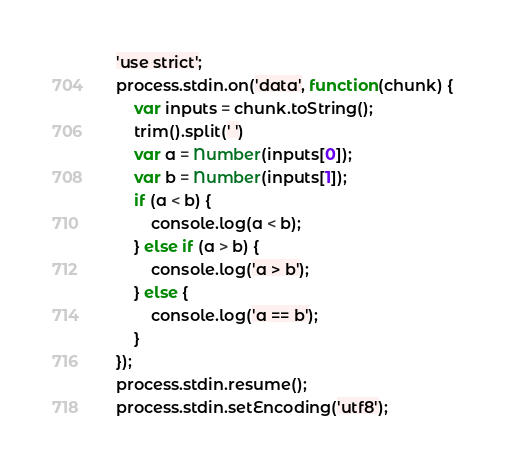Convert code to text. <code><loc_0><loc_0><loc_500><loc_500><_JavaScript_>'use strict';
process.stdin.on('data', function(chunk) {
    var inputs = chunk.toString();
    trim().split(' ')
    var a = Number(inputs[0]);
    var b = Number(inputs[1]);
    if (a < b) {
        console.log(a < b);
    } else if (a > b) {
        console.log('a > b');
    } else {
        console.log('a == b');
    }
});
process.stdin.resume();
process.stdin.setEncoding('utf8');</code> 